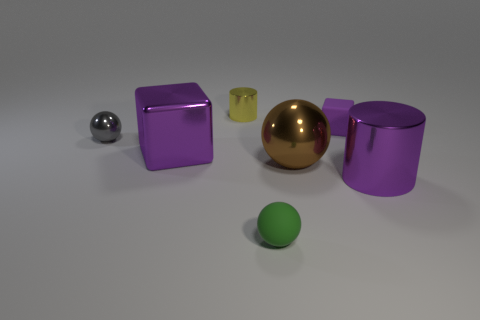What material is the cylinder to the left of the brown thing that is in front of the small ball that is on the left side of the small green matte sphere made of?
Provide a succinct answer. Metal. What is the material of the large purple object that is to the right of the green sphere?
Provide a succinct answer. Metal. There is a tiny thing that is in front of the large brown metal thing; how many small purple things are behind it?
Offer a very short reply. 1. Do the purple matte block and the gray metal thing have the same size?
Ensure brevity in your answer.  Yes. How many tiny purple things have the same material as the tiny gray sphere?
Your answer should be compact. 0. The gray object that is the same shape as the big brown object is what size?
Your answer should be compact. Small. There is a purple object on the left side of the big brown metallic sphere; is its shape the same as the tiny purple rubber object?
Give a very brief answer. Yes. There is a big purple shiny thing that is behind the big thing right of the matte block; what shape is it?
Provide a short and direct response. Cube. Are there any other things that have the same shape as the large brown thing?
Provide a short and direct response. Yes. What color is the other thing that is the same shape as the yellow thing?
Offer a very short reply. Purple. 